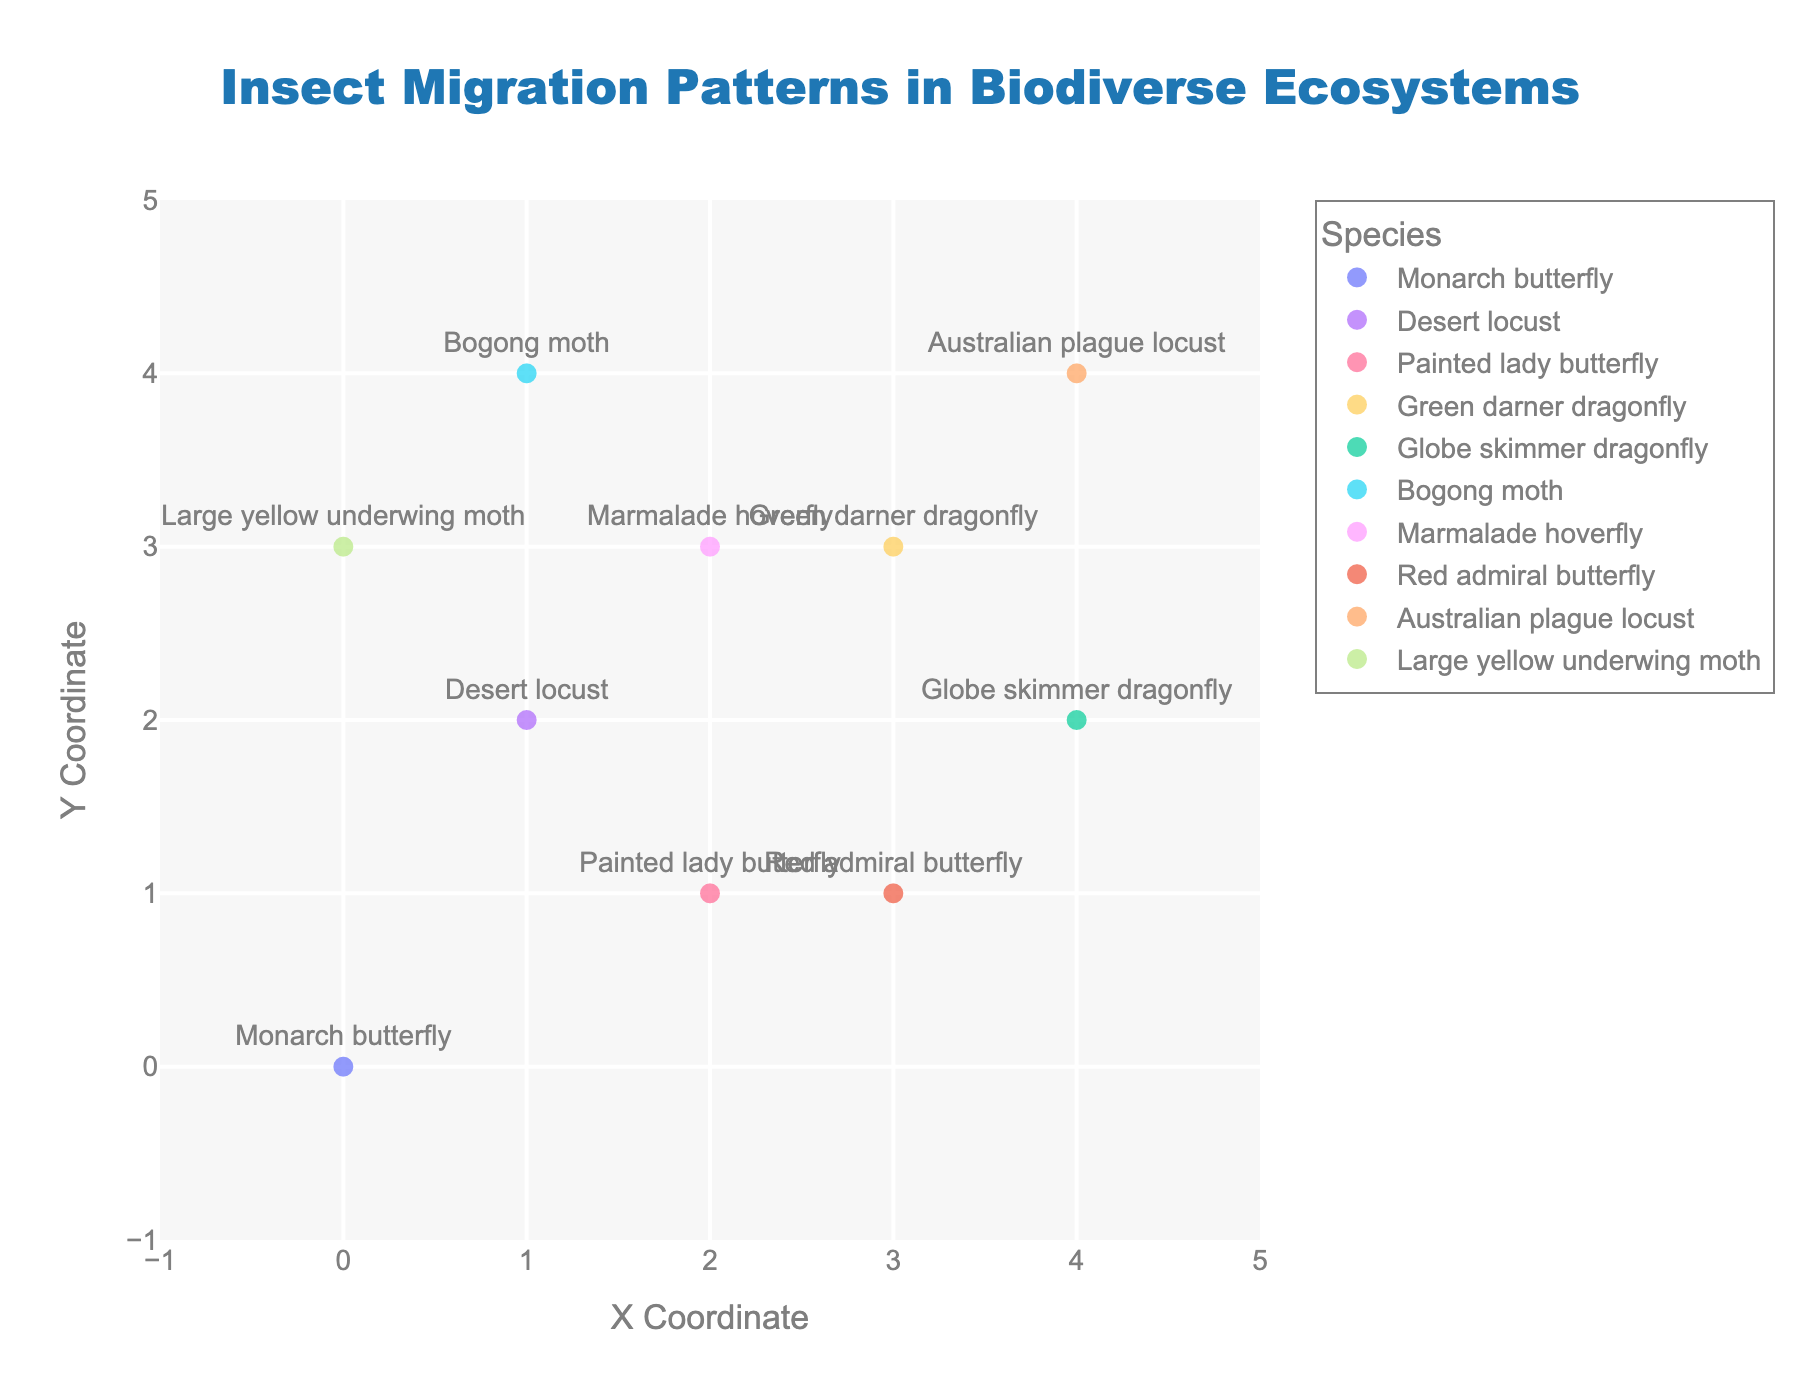What's the title of the figure? The title of the figure is typically placed at the top center. The title in this figure reads "Insect Migration Patterns in Biodiverse Ecosystems".
Answer: Insect Migration Patterns in Biodiverse Ecosystems Which axis is labeled "Y Coordinate"? By looking at the figure, the label for the Y-axis is "Y Coordinate" which is generally placed along the vertical axis.
Answer: Y-axis How many species are represented in the plot? There are individual markers for each species along with labels. By counting unique labels, we can determine the number of species.
Answer: 10 Which insect migrates in the direction of the vector (2, 3)? We need to find the vector components (u=2, v=3) in the data and match it with the corresponding species. The Monarch butterfly has the vector (2, 3).
Answer: Monarch butterfly Which species has the shortest migration vector from the origin? To determine the shortest migration vector, we calculate the magnitude of each vector (sqrt(u^2 + v^2)). The Large yellow underwing moth with vector (1, -1) has the shortest migration vector.
Answer: Large yellow underwing moth Which insect migrates towards the negative Y-axis? We look for vectors with a negative y-component (v). The insects migrating towards the negative Y-axis include Painted lady butterfly, Green darner dragonfly, Marmalade hoverfly, Red admiral butterfly, and Large yellow underwing moth.
Answer: Painted lady butterfly, Green darner dragonfly, Marmalade hoverfly, Red admiral butterfly, Large yellow underwing moth Compare the migration vectors of the Desert locust and the Australian plague locust. Which one has a greater magnitude? Calculate the magnitude of both vectors. For the Desert locust, the vector is (-1, 2) => sqrt((-1)^2 + 2^2) = sqrt(5). For the Australian plague locust, the vector is (3, 2) => sqrt(3^2 + 2^2) = sqrt(13). The Australian plague locust has a greater magnitude.
Answer: Australian plague locust Which species has the most southern end point after migration? The southern end point depends on the y-coordinate after migration (y + v). Find the species with the lowest y + v value. The Red admiral butterfly ends at (3, 1 + (-3)) = (3, -2).
Answer: Red admiral butterfly What is the average displacement for the Desert locust and the Red admiral butterfly in the X direction? Calculate the average displacement by summing the x-components of the vectors and dividing by the number of vectors. Desert locust (x=1, u=-1), Red admiral butterfly (x=3, u=-1): Average = (1 + 3) / 2 = 2. Note that this calculation is questioned specifically for their migration in x direction only, displacement u=-1 for both. Hence the average change in x is -1
Answer: -1 What is the median Y-coordinate of the given species before migration? The Y-coordinates before migration are 0, 2, 1, 3, 2, 4, 3, 1, 4, 3. Arranging in ascending order gives 0, 1, 1, 2, 2, 3, 3, 3, 4, 4. The median Y-coordinate is found between the 5th and 6th values, which are 2 and 3 respectively. The median is (2+3)/2 = 2.5.
Answer: 2.5 